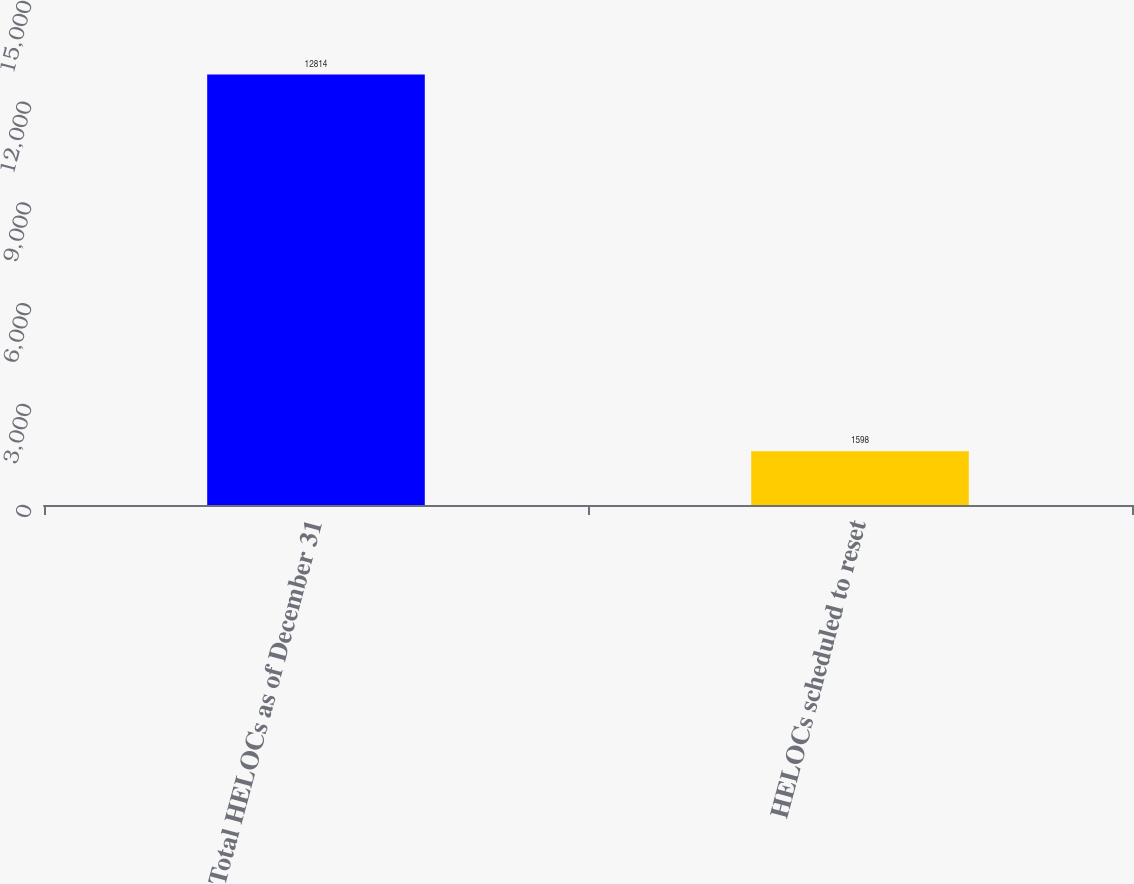<chart> <loc_0><loc_0><loc_500><loc_500><bar_chart><fcel>Total HELOCs as of December 31<fcel>HELOCs scheduled to reset<nl><fcel>12814<fcel>1598<nl></chart> 